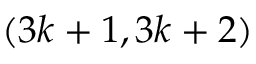<formula> <loc_0><loc_0><loc_500><loc_500>( 3 k + 1 , 3 k + 2 )</formula> 